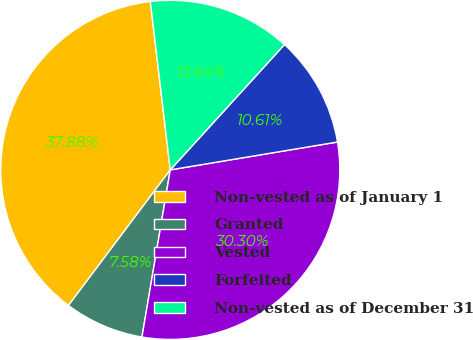Convert chart. <chart><loc_0><loc_0><loc_500><loc_500><pie_chart><fcel>Non-vested as of January 1<fcel>Granted<fcel>Vested<fcel>Forfeited<fcel>Non-vested as of December 31<nl><fcel>37.88%<fcel>7.58%<fcel>30.3%<fcel>10.61%<fcel>13.64%<nl></chart> 